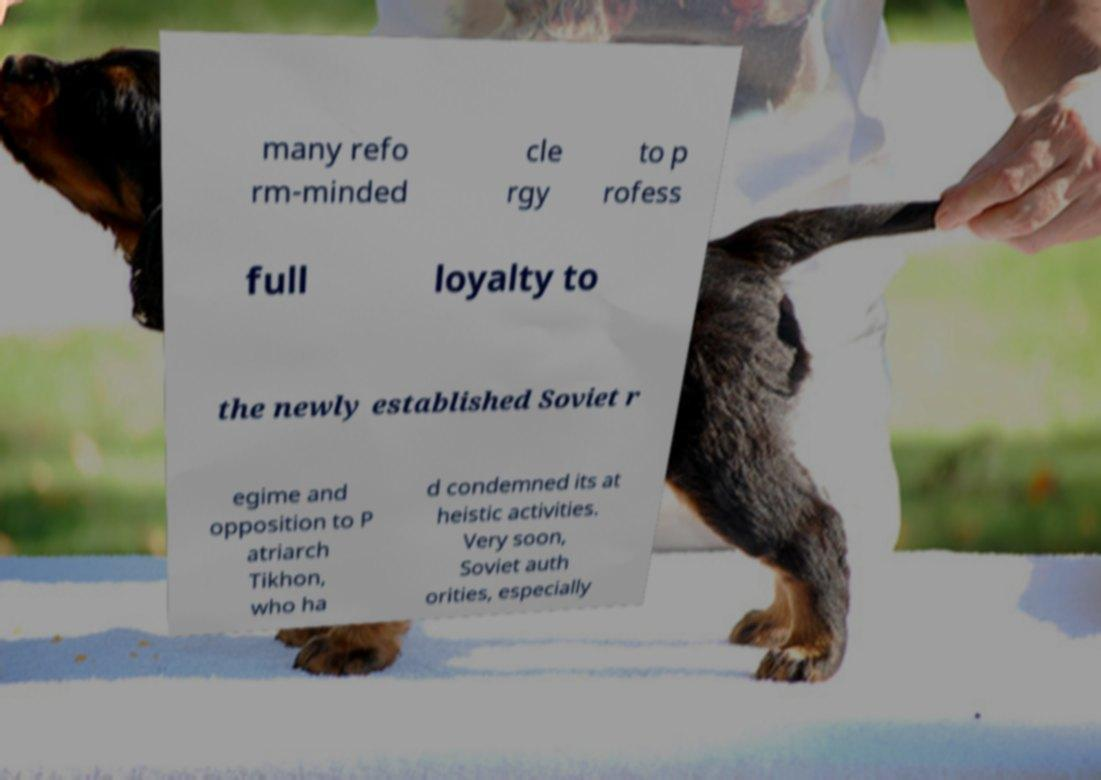There's text embedded in this image that I need extracted. Can you transcribe it verbatim? many refo rm-minded cle rgy to p rofess full loyalty to the newly established Soviet r egime and opposition to P atriarch Tikhon, who ha d condemned its at heistic activities. Very soon, Soviet auth orities, especially 